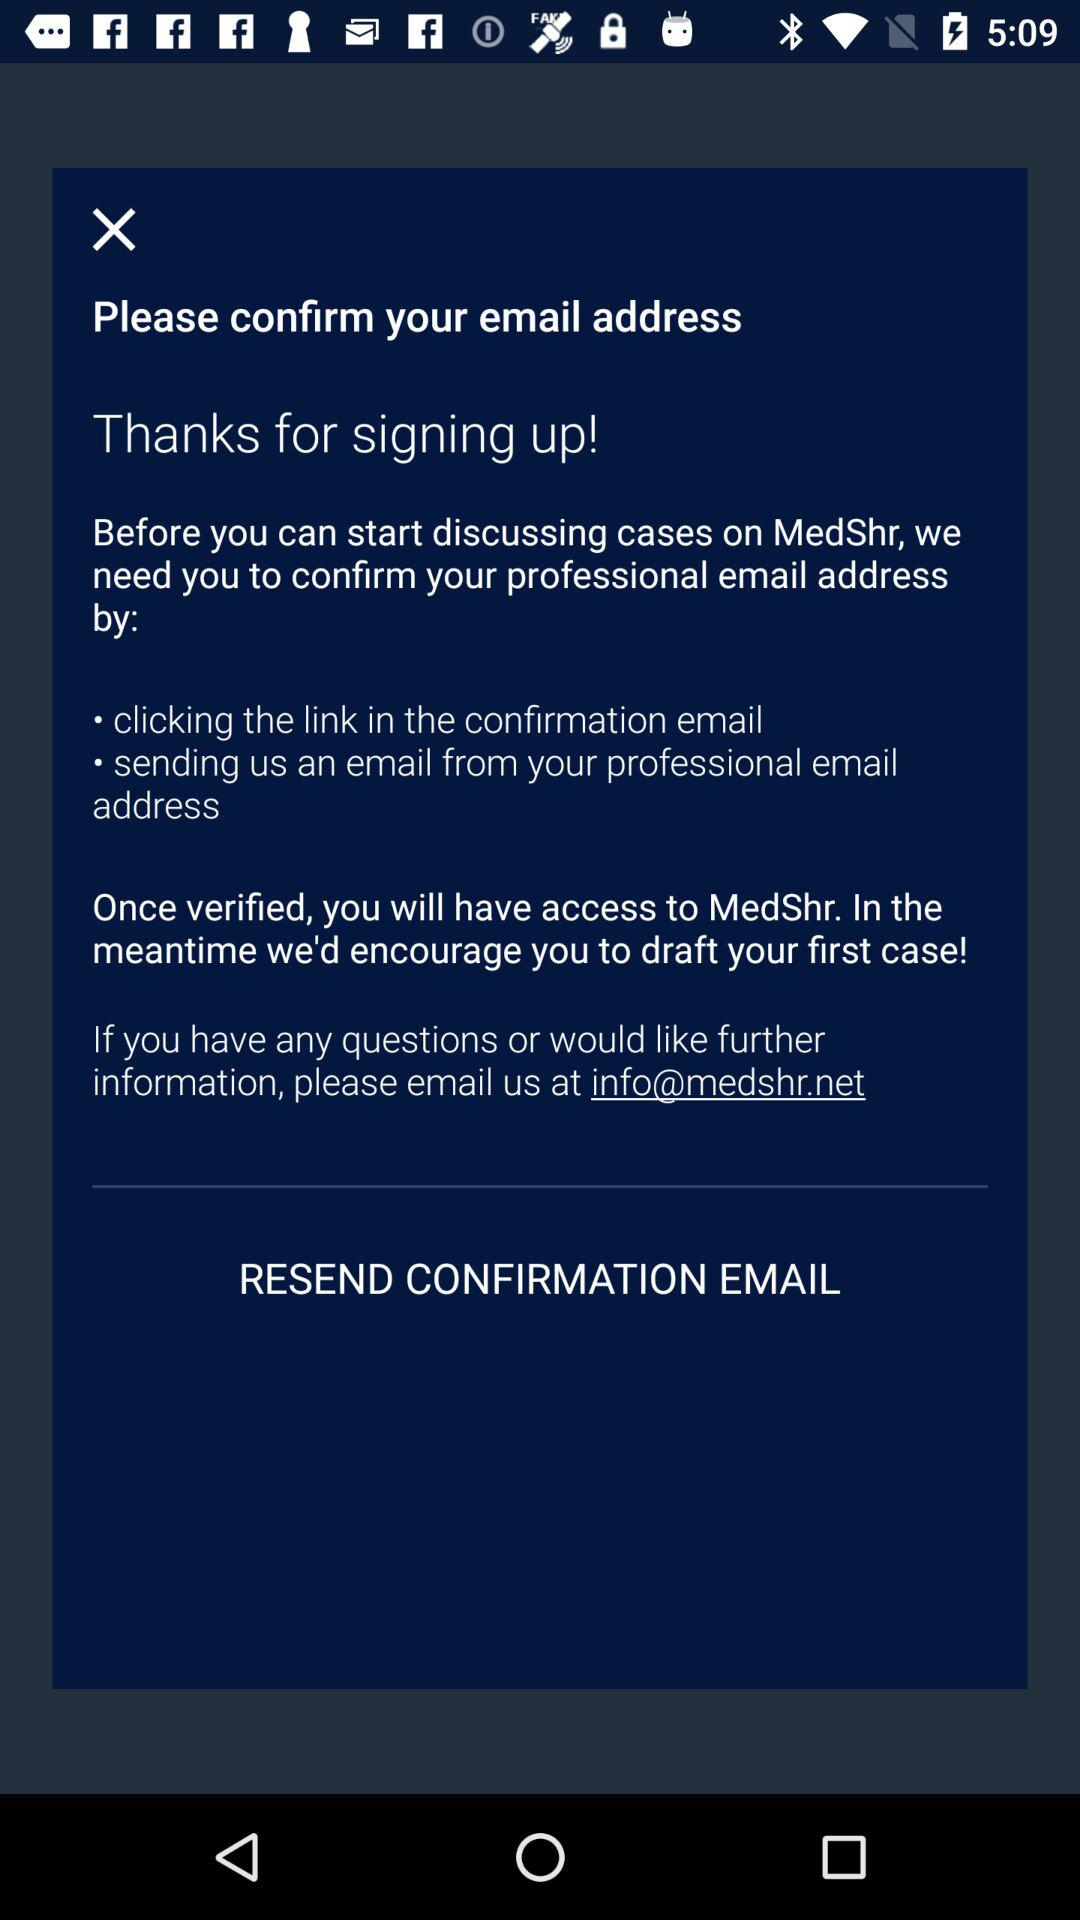What is the contact email address? The contact email address is info@medshr.net. 